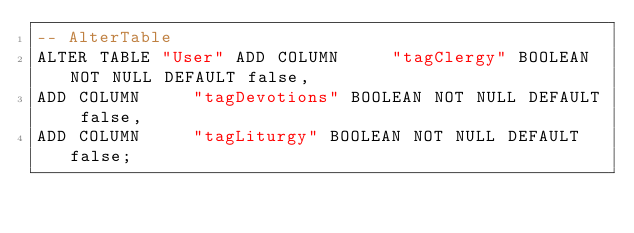Convert code to text. <code><loc_0><loc_0><loc_500><loc_500><_SQL_>-- AlterTable
ALTER TABLE "User" ADD COLUMN     "tagClergy" BOOLEAN NOT NULL DEFAULT false,
ADD COLUMN     "tagDevotions" BOOLEAN NOT NULL DEFAULT false,
ADD COLUMN     "tagLiturgy" BOOLEAN NOT NULL DEFAULT false;
</code> 